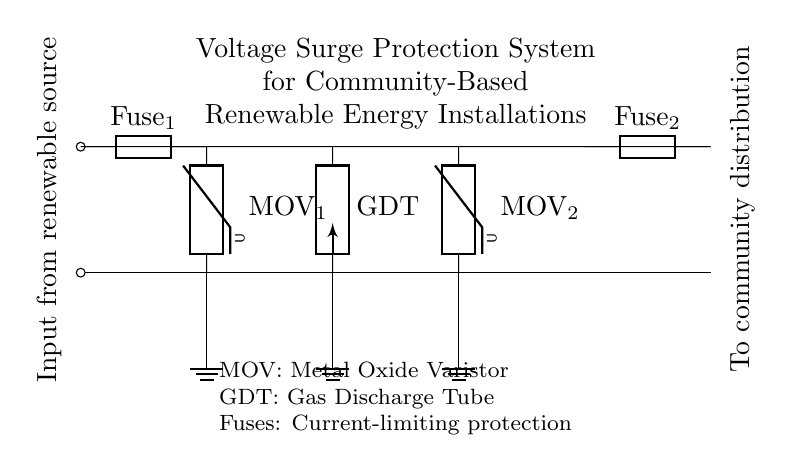What components are used in the voltage surge protection system? The circuit diagram includes two metal oxide varistors (MOV), one gas discharge tube (GDT), and two fuses. These components are labeled directly on the diagram, which provides a straightforward identification of each part.
Answer: metal oxide varistors, gas discharge tube, fuses Where is the input from the renewable source connected? The input from the renewable source is connected at the left side of the diagram where the first short line is shown (0,0) to (0,2). The labels further indicate that this is the entry point of electrical energy into the system.
Answer: Left side What is the purpose of the fuses in this circuit? Fuses are included to provide current-limiting protection, which stops excessive current flow that could damage components. They are strategically placed at both the input and output sides of the system to protect it from surges in different sections.
Answer: Current-limiting protection How many components are grounded in the circuit? There are three components connected to the ground, which include the two metal oxide varistors and the gas discharge tube. This grounding helps to ensure that any voltage surge has a safe path to dissipate, enhancing the protection of the system.
Answer: Three What does GDT stand for in this context? GDT stands for gas discharge tube, which is specifically designed to divert excessive voltage away from sensitive components. It is shown in the circuit at the center, and its function is essential in managing voltage spikes effectively.
Answer: Gas discharge tube What is the function of the metal oxide varistors in this system? Metal oxide varistors (MOV) are used to suppress voltage surges by diverting excess voltage away from sensitive devices, thus protecting the entire installation. Their position in the circuit diagram indicates they are critical for surge protection at designated points.
Answer: Suppress voltage surges How does the configuration of the protection circuit help prevent damage from voltage spikes? The circuit is designed with redundancy, including multiple protective components (two MOVs and a GDT), which means that if one component fails or is overwhelmed, others will still function to protect the system. The placement and combination work together to effectively clamp voltage surges before they can reach the community distribution system.
Answer: Redundant protective components 